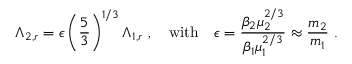Convert formula to latex. <formula><loc_0><loc_0><loc_500><loc_500>\Lambda _ { 2 , r } = \epsilon \left ( \frac { 5 } { 3 } \right ) ^ { 1 / 3 } \Lambda _ { 1 , r } \ , \quad w i t h \quad \epsilon = \frac { \beta _ { 2 } \mu _ { 2 } ^ { 2 / 3 } } { \beta _ { 1 } \mu _ { 1 } ^ { 2 / 3 } } \approx \frac { m _ { 2 } } { m _ { 1 } } \ .</formula> 